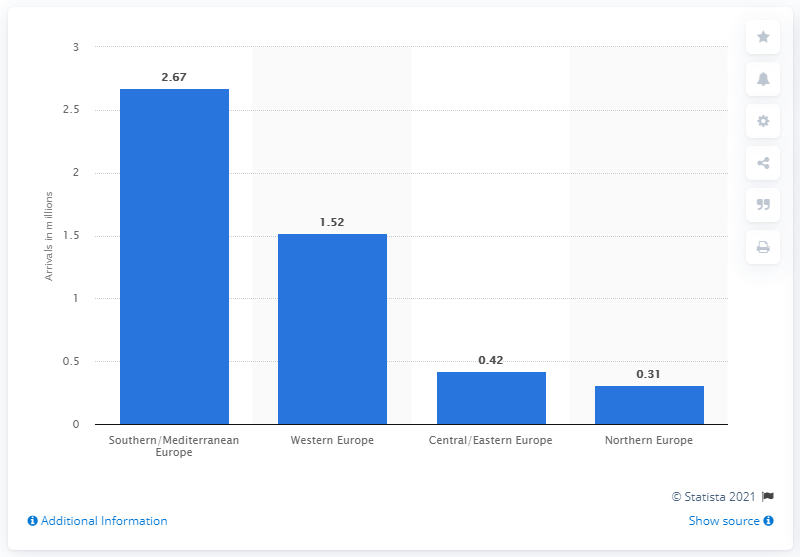Mention a couple of crucial points in this snapshot. Brazilian tourists visited the Southern/Mediterranean region the most in 2019. 